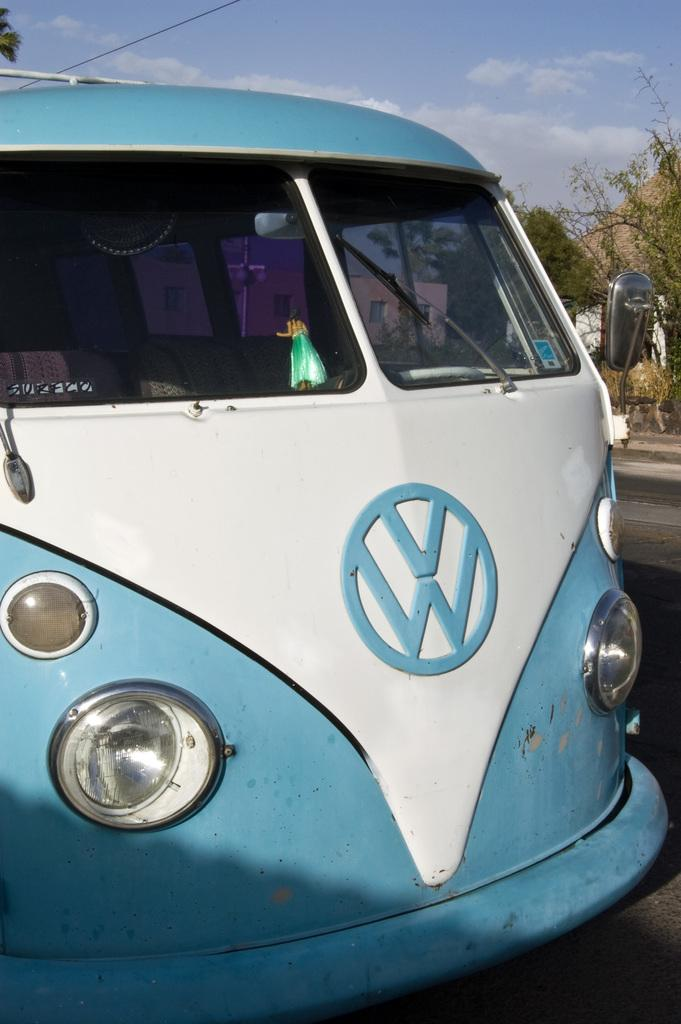<image>
Describe the image concisely. Volkswagon van that is blue and white on a highway 